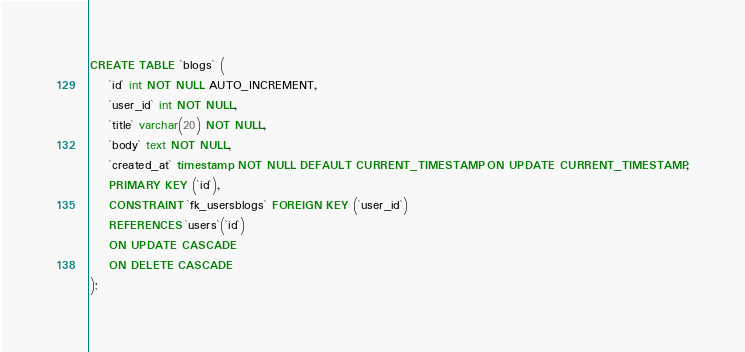<code> <loc_0><loc_0><loc_500><loc_500><_SQL_>CREATE TABLE `blogs` (
    `id` int NOT NULL AUTO_INCREMENT,
    `user_id` int NOT NULL,
    `title` varchar(20) NOT NULL,
    `body` text NOT NULL,
    `created_at` timestamp NOT NULL DEFAULT CURRENT_TIMESTAMP ON UPDATE CURRENT_TIMESTAMP,
    PRIMARY KEY (`id`),
    CONSTRAINT `fk_usersblogs` FOREIGN KEY (`user_id`)
    REFERENCES `users`(`id`)
    ON UPDATE CASCADE
    ON DELETE CASCADE
);</code> 